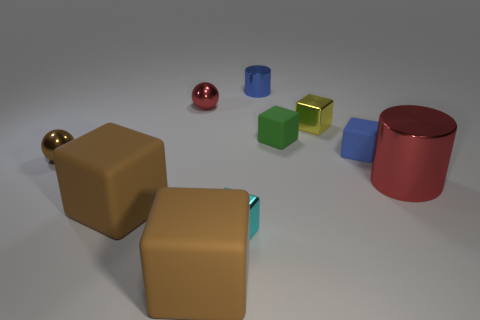There is a metallic object that is on the right side of the blue shiny cylinder and in front of the yellow metallic block; what is its size?
Your answer should be very brief. Large. There is a block that is right of the red ball and on the left side of the small cyan object; what color is it?
Your answer should be very brief. Brown. Are there any other things that are the same color as the tiny cylinder?
Ensure brevity in your answer.  Yes. There is a small cube in front of the tiny metallic sphere in front of the yellow shiny block; what is its color?
Your response must be concise. Cyan. Does the cyan block have the same size as the red sphere?
Your answer should be very brief. Yes. Are the tiny blue object that is to the right of the green matte object and the cylinder to the right of the small blue rubber cube made of the same material?
Give a very brief answer. No. The metal object left of the red object left of the shiny cylinder that is behind the small red ball is what shape?
Provide a short and direct response. Sphere. Are there more big cyan cylinders than metallic blocks?
Your answer should be very brief. No. Are there any shiny balls?
Provide a succinct answer. Yes. What number of objects are blue things behind the yellow cube or rubber blocks that are on the left side of the tiny cylinder?
Keep it short and to the point. 3. 